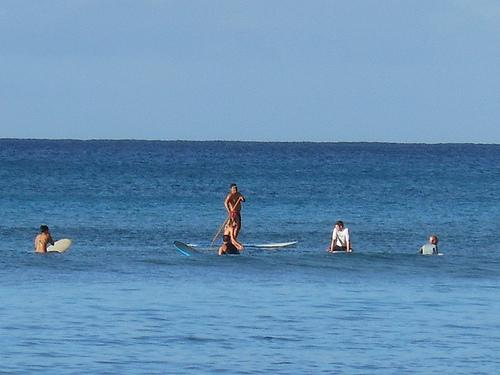Describe the overall atmosphere of the image and the people's actions. A group of surfers is enjoying a sunny day on the calm blue ocean, practicing their skills and waiting for waves. Highlight the clothing and outfit details of the people in the image. People are wearing different colored shirts, like white, black, and blue, and a woman is wearing a bikini top. Write about the weather and water conditions in the image. The image has clear blue skies, calm ocean waters, and no visible clouds. Write about the interactions between people in the image. A woman is sitting in front of a man, and several people are together waiting for waves as a group. Enumerate the various postures and actions of the people on surfboards. People are sitting, standing, paddling, holding a surfboard, and waiting for a wave. List the different colors of surfboards visible in the image. There are white, black, and blue surfboards in the image. Mention the different types of people in the image based on their appearance. The image includes people wearing different colored shirts, a bald person, a woman with a bikini top, and a person looking to the left. Explain the position of the surfboards in the water and their visibility. Some surfboards are partially visible, while others are almost fully visible, with half of one surfboard submerged in water. Mention the primary activity taking place in the image along with the location. Several people are engaging in surfing and paddling activities in the ocean. Describe the elements of nature present in the image. The image showcases a beautiful blue ocean, cloudless sky, and a group of people enjoying water activities. 